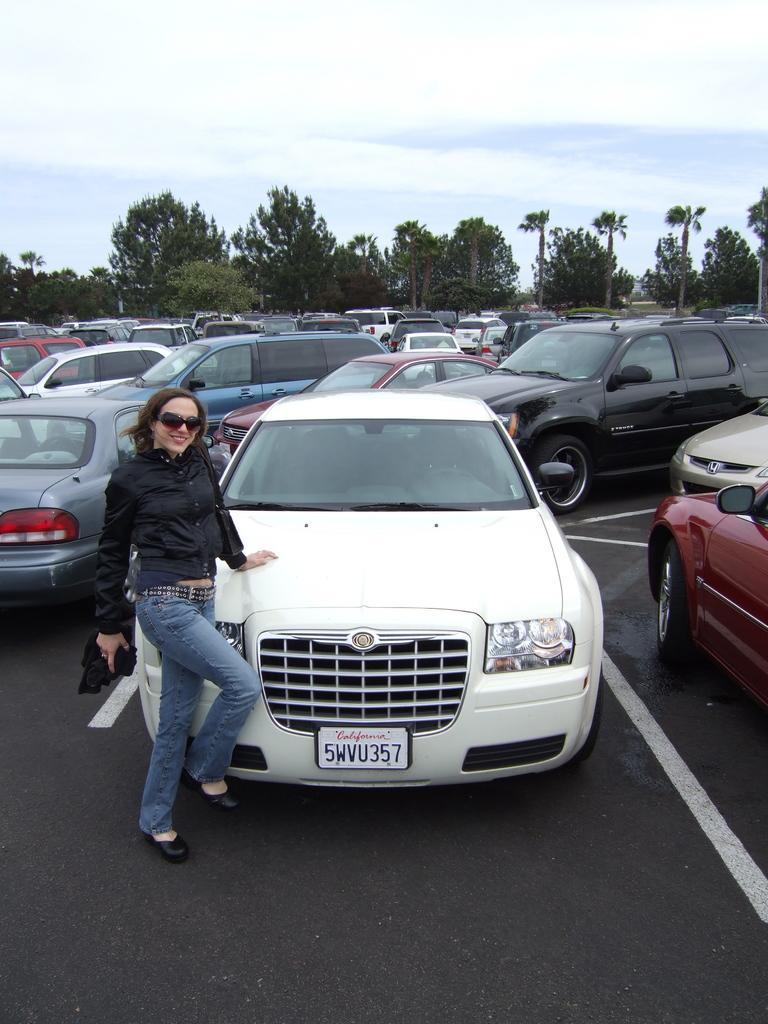What is the lady in the image doing? The lady is standing in front of a car. How many cars can be seen on the road in the image? There are many cars on the road in the image. What is located behind the cars in the image? There are many trees behind the cars in the image. What is visible at the top of the image? The sky is visible at the top of the image. What is the value of the bit in the image? There is no bit present in the image, so it is not possible to determine its value. 